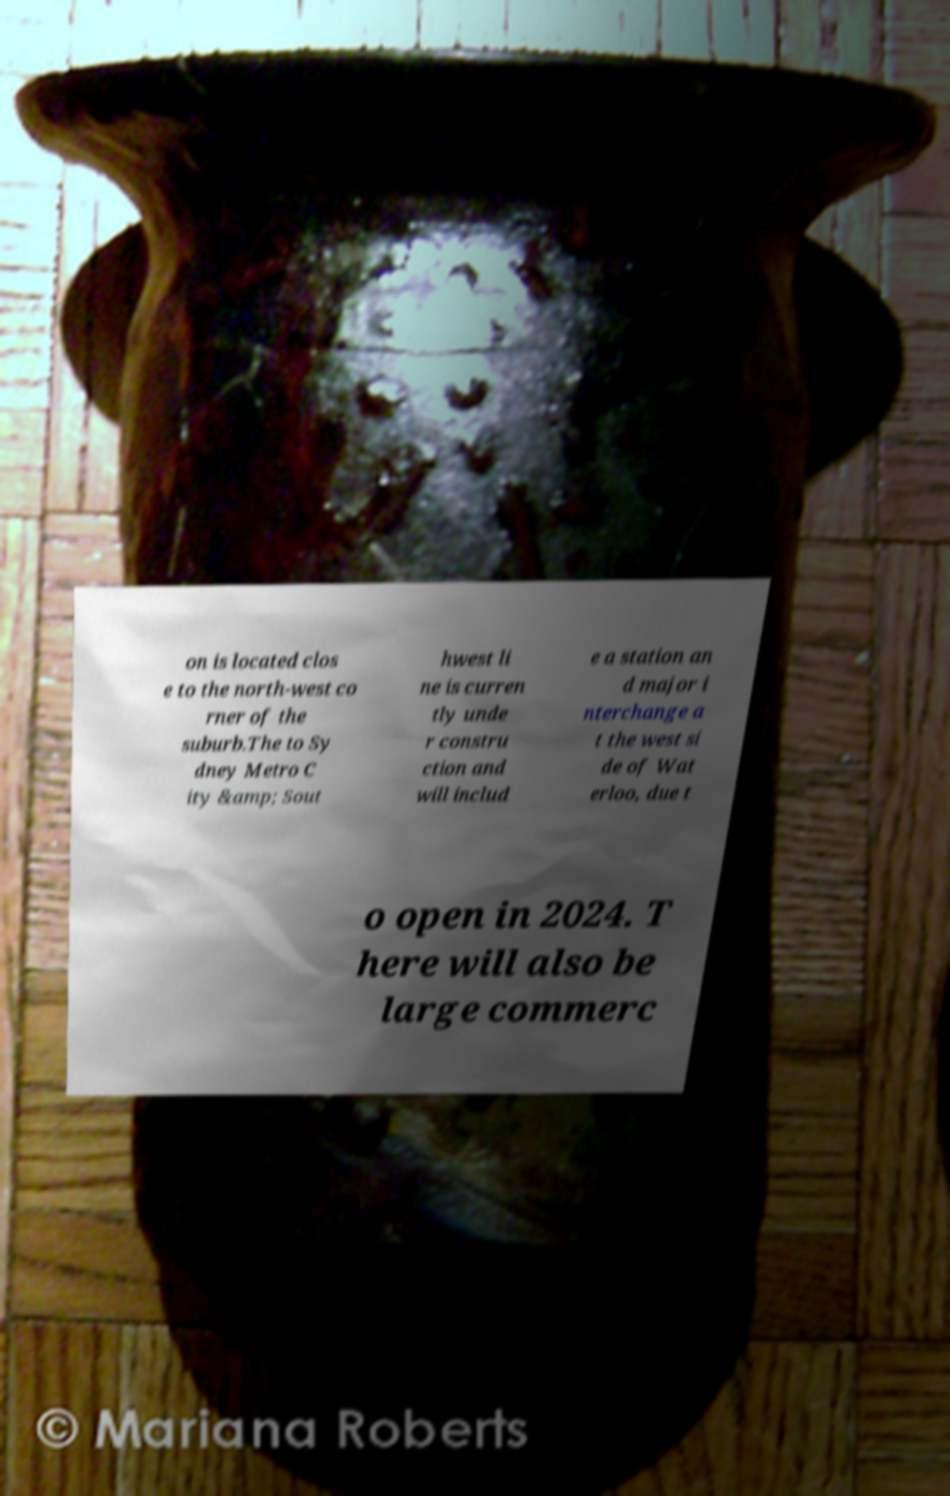Please identify and transcribe the text found in this image. on is located clos e to the north-west co rner of the suburb.The to Sy dney Metro C ity &amp; Sout hwest li ne is curren tly unde r constru ction and will includ e a station an d major i nterchange a t the west si de of Wat erloo, due t o open in 2024. T here will also be large commerc 